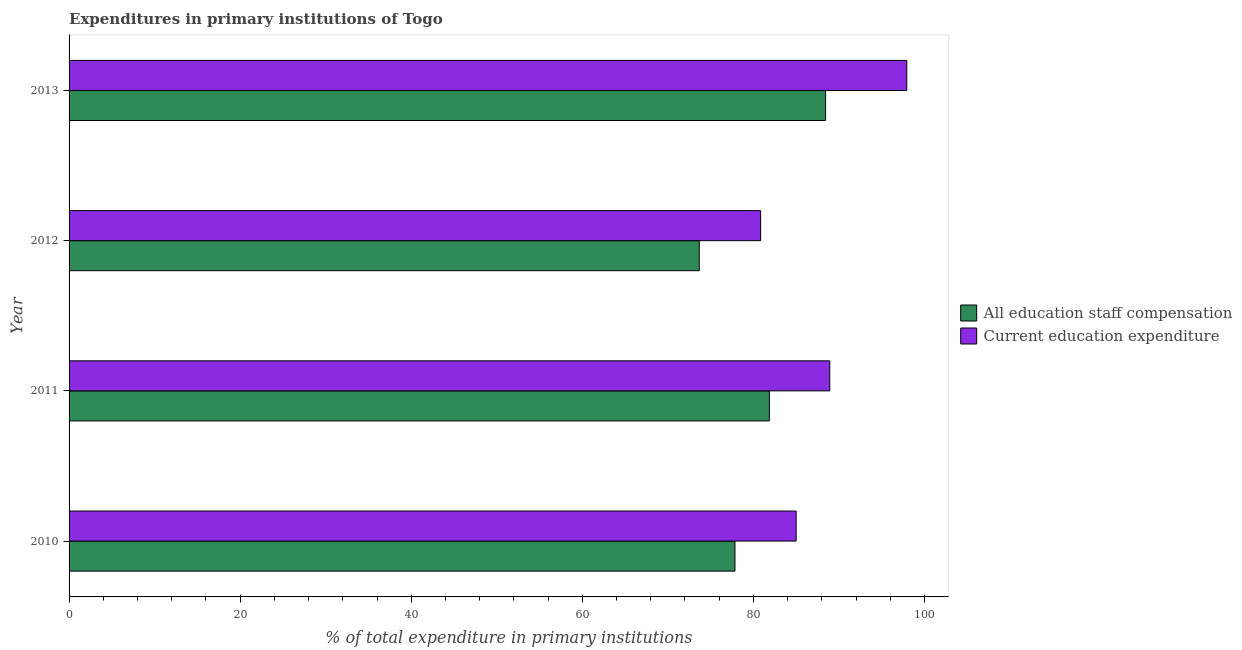How many different coloured bars are there?
Keep it short and to the point. 2. Are the number of bars per tick equal to the number of legend labels?
Make the answer very short. Yes. What is the label of the 4th group of bars from the top?
Provide a succinct answer. 2010. What is the expenditure in education in 2010?
Offer a terse response. 85. Across all years, what is the maximum expenditure in education?
Offer a very short reply. 97.93. Across all years, what is the minimum expenditure in staff compensation?
Your response must be concise. 73.67. What is the total expenditure in staff compensation in the graph?
Give a very brief answer. 321.82. What is the difference between the expenditure in education in 2010 and that in 2013?
Your answer should be very brief. -12.93. What is the difference between the expenditure in staff compensation in 2012 and the expenditure in education in 2013?
Your answer should be very brief. -24.26. What is the average expenditure in staff compensation per year?
Offer a terse response. 80.45. In the year 2012, what is the difference between the expenditure in staff compensation and expenditure in education?
Provide a short and direct response. -7.17. What is the ratio of the expenditure in education in 2010 to that in 2012?
Your answer should be compact. 1.05. What is the difference between the highest and the second highest expenditure in staff compensation?
Your response must be concise. 6.57. What is the difference between the highest and the lowest expenditure in staff compensation?
Offer a very short reply. 14.77. What does the 1st bar from the top in 2010 represents?
Provide a short and direct response. Current education expenditure. What does the 2nd bar from the bottom in 2011 represents?
Keep it short and to the point. Current education expenditure. Are all the bars in the graph horizontal?
Your answer should be compact. Yes. How many years are there in the graph?
Your response must be concise. 4. Does the graph contain any zero values?
Your answer should be compact. No. What is the title of the graph?
Give a very brief answer. Expenditures in primary institutions of Togo. Does "Taxes on profits and capital gains" appear as one of the legend labels in the graph?
Your answer should be very brief. No. What is the label or title of the X-axis?
Make the answer very short. % of total expenditure in primary institutions. What is the label or title of the Y-axis?
Ensure brevity in your answer.  Year. What is the % of total expenditure in primary institutions in All education staff compensation in 2010?
Your answer should be very brief. 77.85. What is the % of total expenditure in primary institutions of Current education expenditure in 2010?
Your answer should be compact. 85. What is the % of total expenditure in primary institutions in All education staff compensation in 2011?
Keep it short and to the point. 81.87. What is the % of total expenditure in primary institutions in Current education expenditure in 2011?
Offer a very short reply. 88.93. What is the % of total expenditure in primary institutions of All education staff compensation in 2012?
Provide a succinct answer. 73.67. What is the % of total expenditure in primary institutions in Current education expenditure in 2012?
Make the answer very short. 80.84. What is the % of total expenditure in primary institutions of All education staff compensation in 2013?
Offer a very short reply. 88.44. What is the % of total expenditure in primary institutions in Current education expenditure in 2013?
Keep it short and to the point. 97.93. Across all years, what is the maximum % of total expenditure in primary institutions of All education staff compensation?
Ensure brevity in your answer.  88.44. Across all years, what is the maximum % of total expenditure in primary institutions of Current education expenditure?
Offer a terse response. 97.93. Across all years, what is the minimum % of total expenditure in primary institutions in All education staff compensation?
Offer a terse response. 73.67. Across all years, what is the minimum % of total expenditure in primary institutions of Current education expenditure?
Your answer should be compact. 80.84. What is the total % of total expenditure in primary institutions of All education staff compensation in the graph?
Offer a very short reply. 321.82. What is the total % of total expenditure in primary institutions of Current education expenditure in the graph?
Provide a short and direct response. 352.7. What is the difference between the % of total expenditure in primary institutions in All education staff compensation in 2010 and that in 2011?
Offer a very short reply. -4.02. What is the difference between the % of total expenditure in primary institutions in Current education expenditure in 2010 and that in 2011?
Make the answer very short. -3.93. What is the difference between the % of total expenditure in primary institutions of All education staff compensation in 2010 and that in 2012?
Your answer should be compact. 4.18. What is the difference between the % of total expenditure in primary institutions of Current education expenditure in 2010 and that in 2012?
Make the answer very short. 4.15. What is the difference between the % of total expenditure in primary institutions of All education staff compensation in 2010 and that in 2013?
Keep it short and to the point. -10.59. What is the difference between the % of total expenditure in primary institutions in Current education expenditure in 2010 and that in 2013?
Your answer should be very brief. -12.93. What is the difference between the % of total expenditure in primary institutions in All education staff compensation in 2011 and that in 2012?
Ensure brevity in your answer.  8.2. What is the difference between the % of total expenditure in primary institutions of Current education expenditure in 2011 and that in 2012?
Provide a short and direct response. 8.08. What is the difference between the % of total expenditure in primary institutions of All education staff compensation in 2011 and that in 2013?
Ensure brevity in your answer.  -6.57. What is the difference between the % of total expenditure in primary institutions of Current education expenditure in 2011 and that in 2013?
Keep it short and to the point. -9.01. What is the difference between the % of total expenditure in primary institutions in All education staff compensation in 2012 and that in 2013?
Ensure brevity in your answer.  -14.77. What is the difference between the % of total expenditure in primary institutions of Current education expenditure in 2012 and that in 2013?
Make the answer very short. -17.09. What is the difference between the % of total expenditure in primary institutions of All education staff compensation in 2010 and the % of total expenditure in primary institutions of Current education expenditure in 2011?
Your answer should be very brief. -11.08. What is the difference between the % of total expenditure in primary institutions of All education staff compensation in 2010 and the % of total expenditure in primary institutions of Current education expenditure in 2012?
Make the answer very short. -3. What is the difference between the % of total expenditure in primary institutions in All education staff compensation in 2010 and the % of total expenditure in primary institutions in Current education expenditure in 2013?
Offer a very short reply. -20.09. What is the difference between the % of total expenditure in primary institutions in All education staff compensation in 2011 and the % of total expenditure in primary institutions in Current education expenditure in 2012?
Give a very brief answer. 1.02. What is the difference between the % of total expenditure in primary institutions in All education staff compensation in 2011 and the % of total expenditure in primary institutions in Current education expenditure in 2013?
Offer a very short reply. -16.07. What is the difference between the % of total expenditure in primary institutions in All education staff compensation in 2012 and the % of total expenditure in primary institutions in Current education expenditure in 2013?
Give a very brief answer. -24.26. What is the average % of total expenditure in primary institutions of All education staff compensation per year?
Your answer should be compact. 80.45. What is the average % of total expenditure in primary institutions of Current education expenditure per year?
Provide a short and direct response. 88.18. In the year 2010, what is the difference between the % of total expenditure in primary institutions of All education staff compensation and % of total expenditure in primary institutions of Current education expenditure?
Your answer should be very brief. -7.15. In the year 2011, what is the difference between the % of total expenditure in primary institutions in All education staff compensation and % of total expenditure in primary institutions in Current education expenditure?
Make the answer very short. -7.06. In the year 2012, what is the difference between the % of total expenditure in primary institutions of All education staff compensation and % of total expenditure in primary institutions of Current education expenditure?
Your answer should be very brief. -7.18. In the year 2013, what is the difference between the % of total expenditure in primary institutions in All education staff compensation and % of total expenditure in primary institutions in Current education expenditure?
Your answer should be very brief. -9.49. What is the ratio of the % of total expenditure in primary institutions in All education staff compensation in 2010 to that in 2011?
Provide a short and direct response. 0.95. What is the ratio of the % of total expenditure in primary institutions of Current education expenditure in 2010 to that in 2011?
Your answer should be compact. 0.96. What is the ratio of the % of total expenditure in primary institutions in All education staff compensation in 2010 to that in 2012?
Keep it short and to the point. 1.06. What is the ratio of the % of total expenditure in primary institutions in Current education expenditure in 2010 to that in 2012?
Offer a terse response. 1.05. What is the ratio of the % of total expenditure in primary institutions in All education staff compensation in 2010 to that in 2013?
Ensure brevity in your answer.  0.88. What is the ratio of the % of total expenditure in primary institutions in Current education expenditure in 2010 to that in 2013?
Your answer should be compact. 0.87. What is the ratio of the % of total expenditure in primary institutions in All education staff compensation in 2011 to that in 2012?
Give a very brief answer. 1.11. What is the ratio of the % of total expenditure in primary institutions of All education staff compensation in 2011 to that in 2013?
Your response must be concise. 0.93. What is the ratio of the % of total expenditure in primary institutions of Current education expenditure in 2011 to that in 2013?
Offer a very short reply. 0.91. What is the ratio of the % of total expenditure in primary institutions in All education staff compensation in 2012 to that in 2013?
Offer a terse response. 0.83. What is the ratio of the % of total expenditure in primary institutions in Current education expenditure in 2012 to that in 2013?
Ensure brevity in your answer.  0.83. What is the difference between the highest and the second highest % of total expenditure in primary institutions in All education staff compensation?
Provide a short and direct response. 6.57. What is the difference between the highest and the second highest % of total expenditure in primary institutions in Current education expenditure?
Ensure brevity in your answer.  9.01. What is the difference between the highest and the lowest % of total expenditure in primary institutions of All education staff compensation?
Offer a very short reply. 14.77. What is the difference between the highest and the lowest % of total expenditure in primary institutions in Current education expenditure?
Provide a short and direct response. 17.09. 